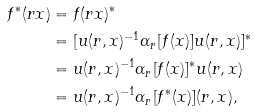<formula> <loc_0><loc_0><loc_500><loc_500>f ^ { * } ( r x ) & = f ( r x ) ^ { * } \\ & = [ u ( r , x ) ^ { - 1 } \alpha _ { r } [ f ( x ) ] u ( r , x ) ] ^ { * } \\ & = u ( r , x ) ^ { - 1 } \alpha _ { r } [ f ( x ) ] ^ { * } u ( r , x ) \\ & = u ( r , x ) ^ { - 1 } \alpha _ { r } [ f ^ { * } ( x ) ] ( r , x ) ,</formula> 